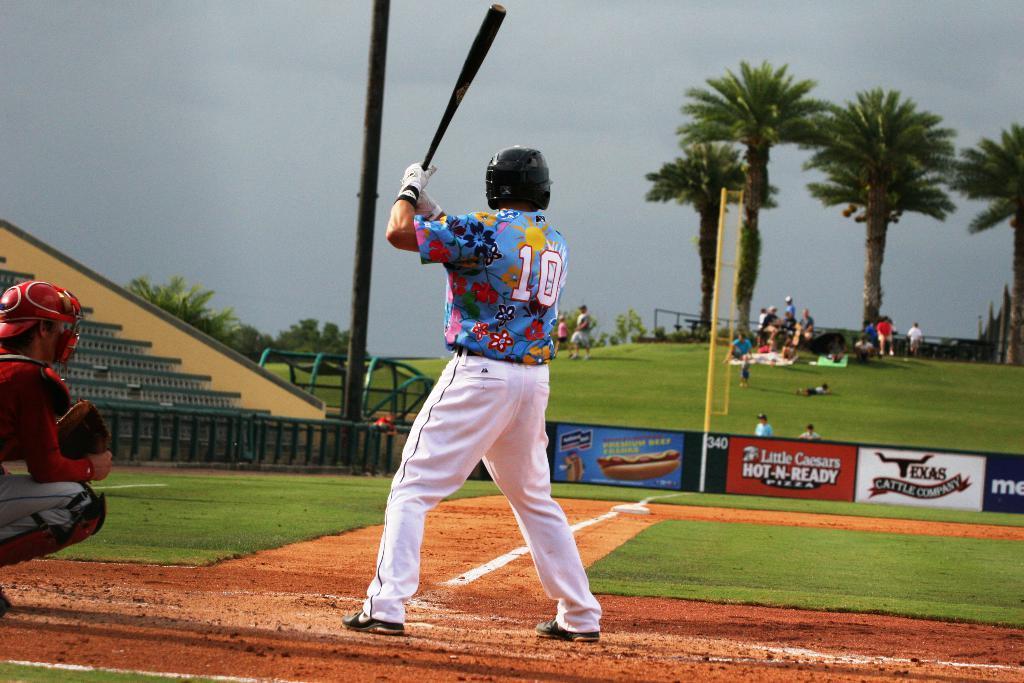How would you summarize this image in a sentence or two? In the picture we can see a grass surface on the hill and near it, we can see a muddy path with two green color mats and a person standing on the path and holding a baseball stick and he is wearing a glove and helmet and on the grass surface, we can see some people are sitting and some are standing near them we can see trees and behind it we can see a sky. 